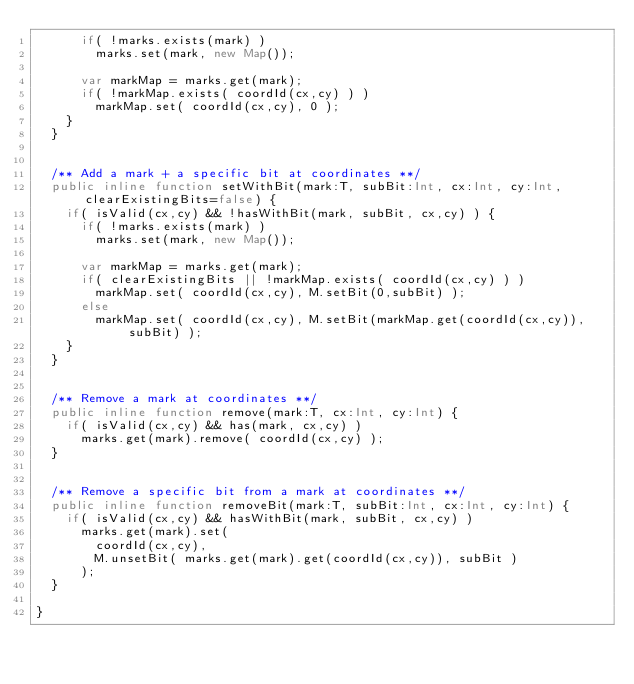Convert code to text. <code><loc_0><loc_0><loc_500><loc_500><_Haxe_>			if( !marks.exists(mark) )
				marks.set(mark, new Map());

			var markMap = marks.get(mark);
			if( !markMap.exists( coordId(cx,cy) ) )
				markMap.set( coordId(cx,cy), 0 );
		}
	}


	/** Add a mark + a specific bit at coordinates **/
	public inline function setWithBit(mark:T, subBit:Int, cx:Int, cy:Int, clearExistingBits=false) {
		if( isValid(cx,cy) && !hasWithBit(mark, subBit, cx,cy) ) {
			if( !marks.exists(mark) )
				marks.set(mark, new Map());

			var markMap = marks.get(mark);
			if( clearExistingBits || !markMap.exists( coordId(cx,cy) ) )
				markMap.set( coordId(cx,cy), M.setBit(0,subBit) );
			else
				markMap.set( coordId(cx,cy), M.setBit(markMap.get(coordId(cx,cy)), subBit) );
		}
	}


	/** Remove a mark at coordinates **/
	public inline function remove(mark:T, cx:Int, cy:Int) {
		if( isValid(cx,cy) && has(mark, cx,cy) )
			marks.get(mark).remove( coordId(cx,cy) );
	}


	/** Remove a specific bit from a mark at coordinates **/
	public inline function removeBit(mark:T, subBit:Int, cx:Int, cy:Int) {
		if( isValid(cx,cy) && hasWithBit(mark, subBit, cx,cy) )
			marks.get(mark).set(
				coordId(cx,cy),
				M.unsetBit( marks.get(mark).get(coordId(cx,cy)), subBit )
			);
	}

}</code> 